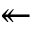<formula> <loc_0><loc_0><loc_500><loc_500>\twoheadleftarrow</formula> 